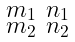Convert formula to latex. <formula><loc_0><loc_0><loc_500><loc_500>\begin{smallmatrix} m _ { 1 } & n _ { 1 } \\ m _ { 2 } & n _ { 2 } \end{smallmatrix}</formula> 